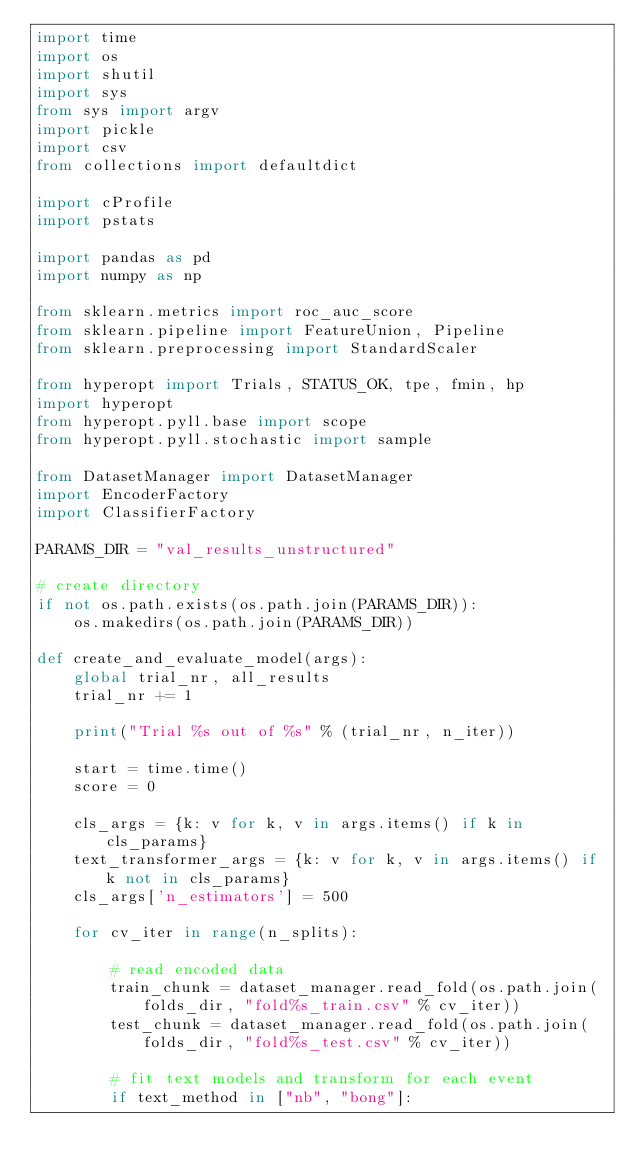<code> <loc_0><loc_0><loc_500><loc_500><_Python_>import time
import os
import shutil
import sys
from sys import argv
import pickle
import csv
from collections import defaultdict

import cProfile
import pstats

import pandas as pd
import numpy as np

from sklearn.metrics import roc_auc_score
from sklearn.pipeline import FeatureUnion, Pipeline
from sklearn.preprocessing import StandardScaler

from hyperopt import Trials, STATUS_OK, tpe, fmin, hp
import hyperopt
from hyperopt.pyll.base import scope
from hyperopt.pyll.stochastic import sample

from DatasetManager import DatasetManager
import EncoderFactory
import ClassifierFactory

PARAMS_DIR = "val_results_unstructured"

# create directory
if not os.path.exists(os.path.join(PARAMS_DIR)):
    os.makedirs(os.path.join(PARAMS_DIR))

def create_and_evaluate_model(args):
    global trial_nr, all_results
    trial_nr += 1
    
    print("Trial %s out of %s" % (trial_nr, n_iter))
    
    start = time.time()
    score = 0
    
    cls_args = {k: v for k, v in args.items() if k in cls_params}
    text_transformer_args = {k: v for k, v in args.items() if k not in cls_params}
    cls_args['n_estimators'] = 500
    
    for cv_iter in range(n_splits):
        
        # read encoded data
        train_chunk = dataset_manager.read_fold(os.path.join(folds_dir, "fold%s_train.csv" % cv_iter))
        test_chunk = dataset_manager.read_fold(os.path.join(folds_dir, "fold%s_test.csv" % cv_iter))
        
        # fit text models and transform for each event
        if text_method in ["nb", "bong"]:</code> 